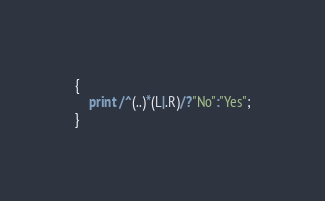Convert code to text. <code><loc_0><loc_0><loc_500><loc_500><_Awk_>{
    print /^(..)*(L|.R)/?"No":"Yes";
}</code> 